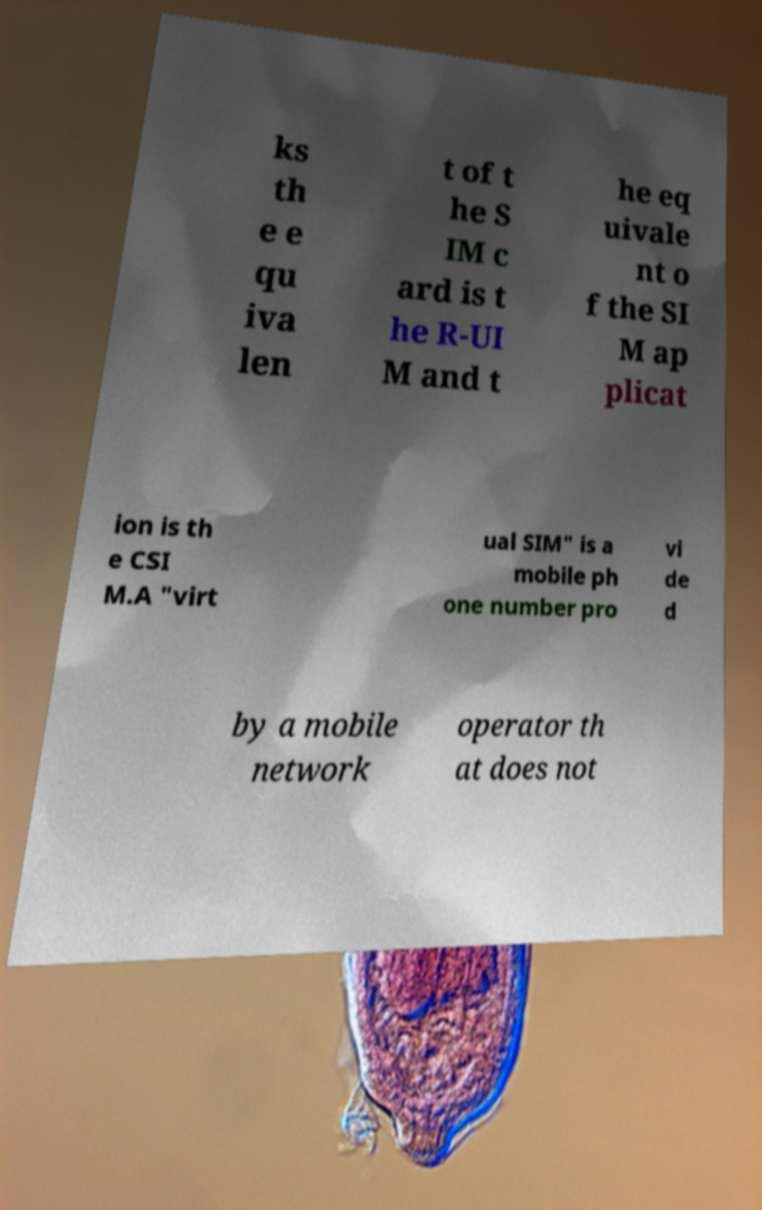For documentation purposes, I need the text within this image transcribed. Could you provide that? ks th e e qu iva len t of t he S IM c ard is t he R-UI M and t he eq uivale nt o f the SI M ap plicat ion is th e CSI M.A "virt ual SIM" is a mobile ph one number pro vi de d by a mobile network operator th at does not 